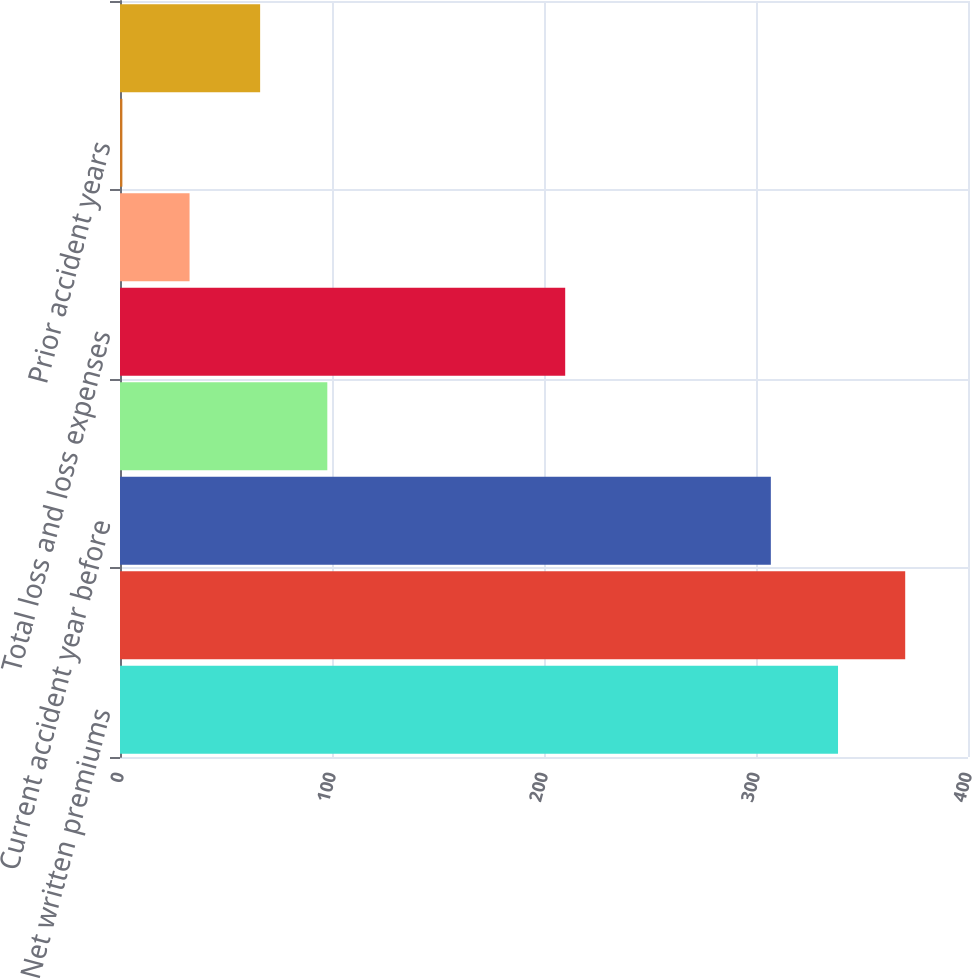Convert chart. <chart><loc_0><loc_0><loc_500><loc_500><bar_chart><fcel>Net written premiums<fcel>Earned premiums<fcel>Current accident year before<fcel>Prior accident years before<fcel>Total loss and loss expenses<fcel>Current accident year<fcel>Prior accident years<fcel>Total loss and loss expense<nl><fcel>338.69<fcel>370.38<fcel>307<fcel>97.79<fcel>210<fcel>32.81<fcel>1.12<fcel>66.1<nl></chart> 